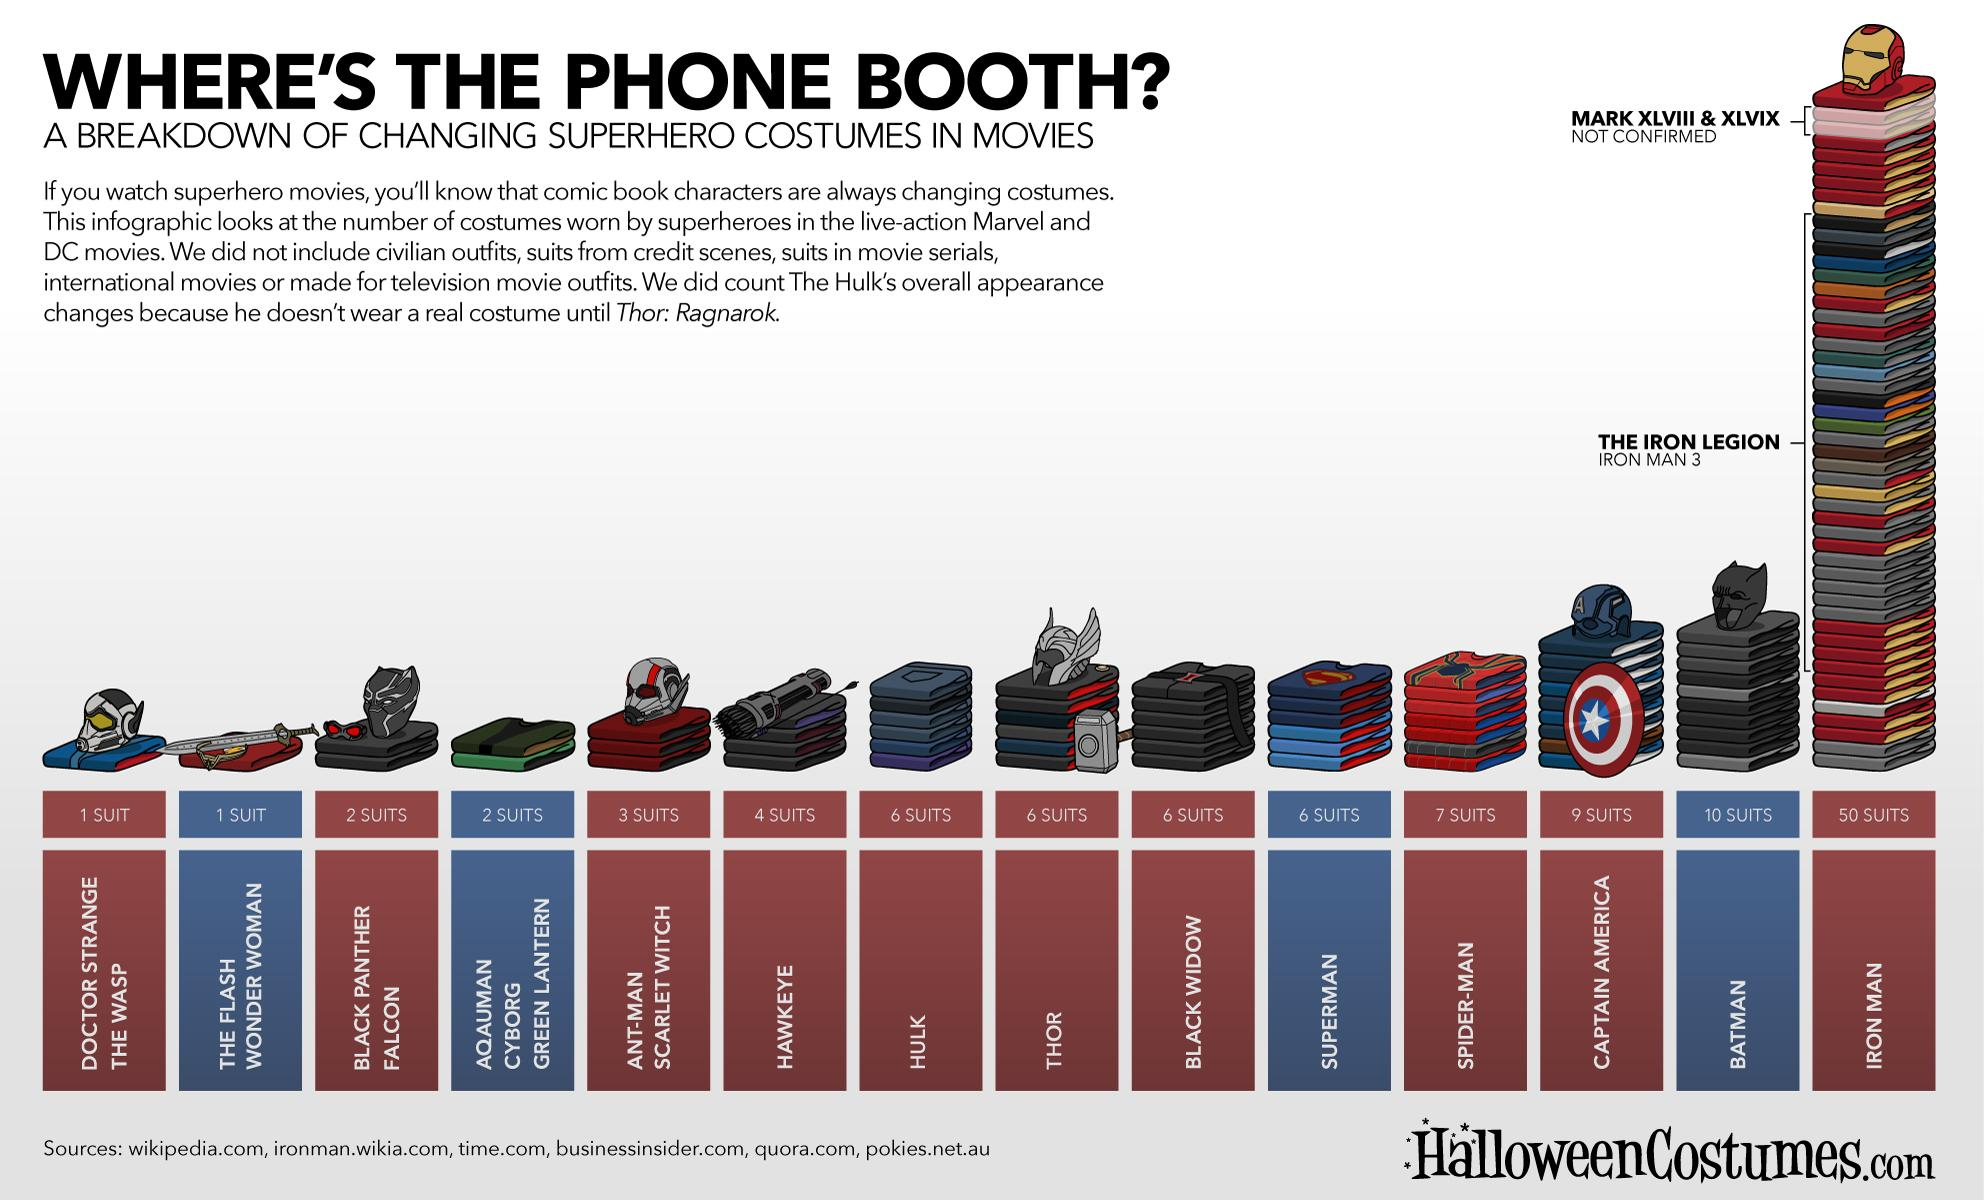List a handful of essential elements in this visual. The number of suits worn by Spider-Man and Iron Man combined is 57. The number of suits worn by Superman and Batman, taken together, is 16. Black Widow and Hawkeye, taken together, wear a total of 10 suits. The number of suits worn by Hulk and Thor, taken together, is twelve. 